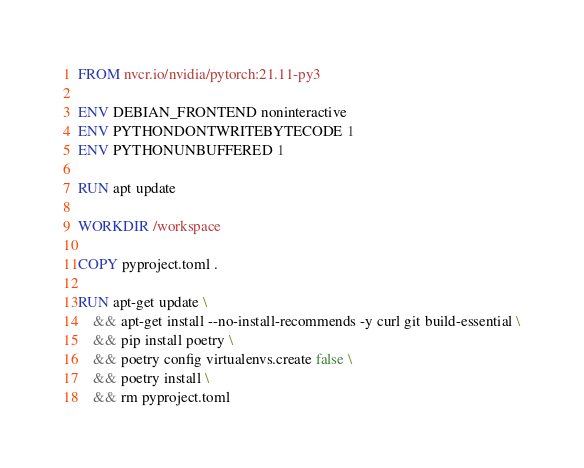Convert code to text. <code><loc_0><loc_0><loc_500><loc_500><_Dockerfile_>FROM nvcr.io/nvidia/pytorch:21.11-py3

ENV DEBIAN_FRONTEND noninteractive
ENV PYTHONDONTWRITEBYTECODE 1
ENV PYTHONUNBUFFERED 1

RUN apt update

WORKDIR /workspace

COPY pyproject.toml .

RUN apt-get update \
    && apt-get install --no-install-recommends -y curl git build-essential \
    && pip install poetry \ 
    && poetry config virtualenvs.create false \
    && poetry install \
    && rm pyproject.toml
</code> 